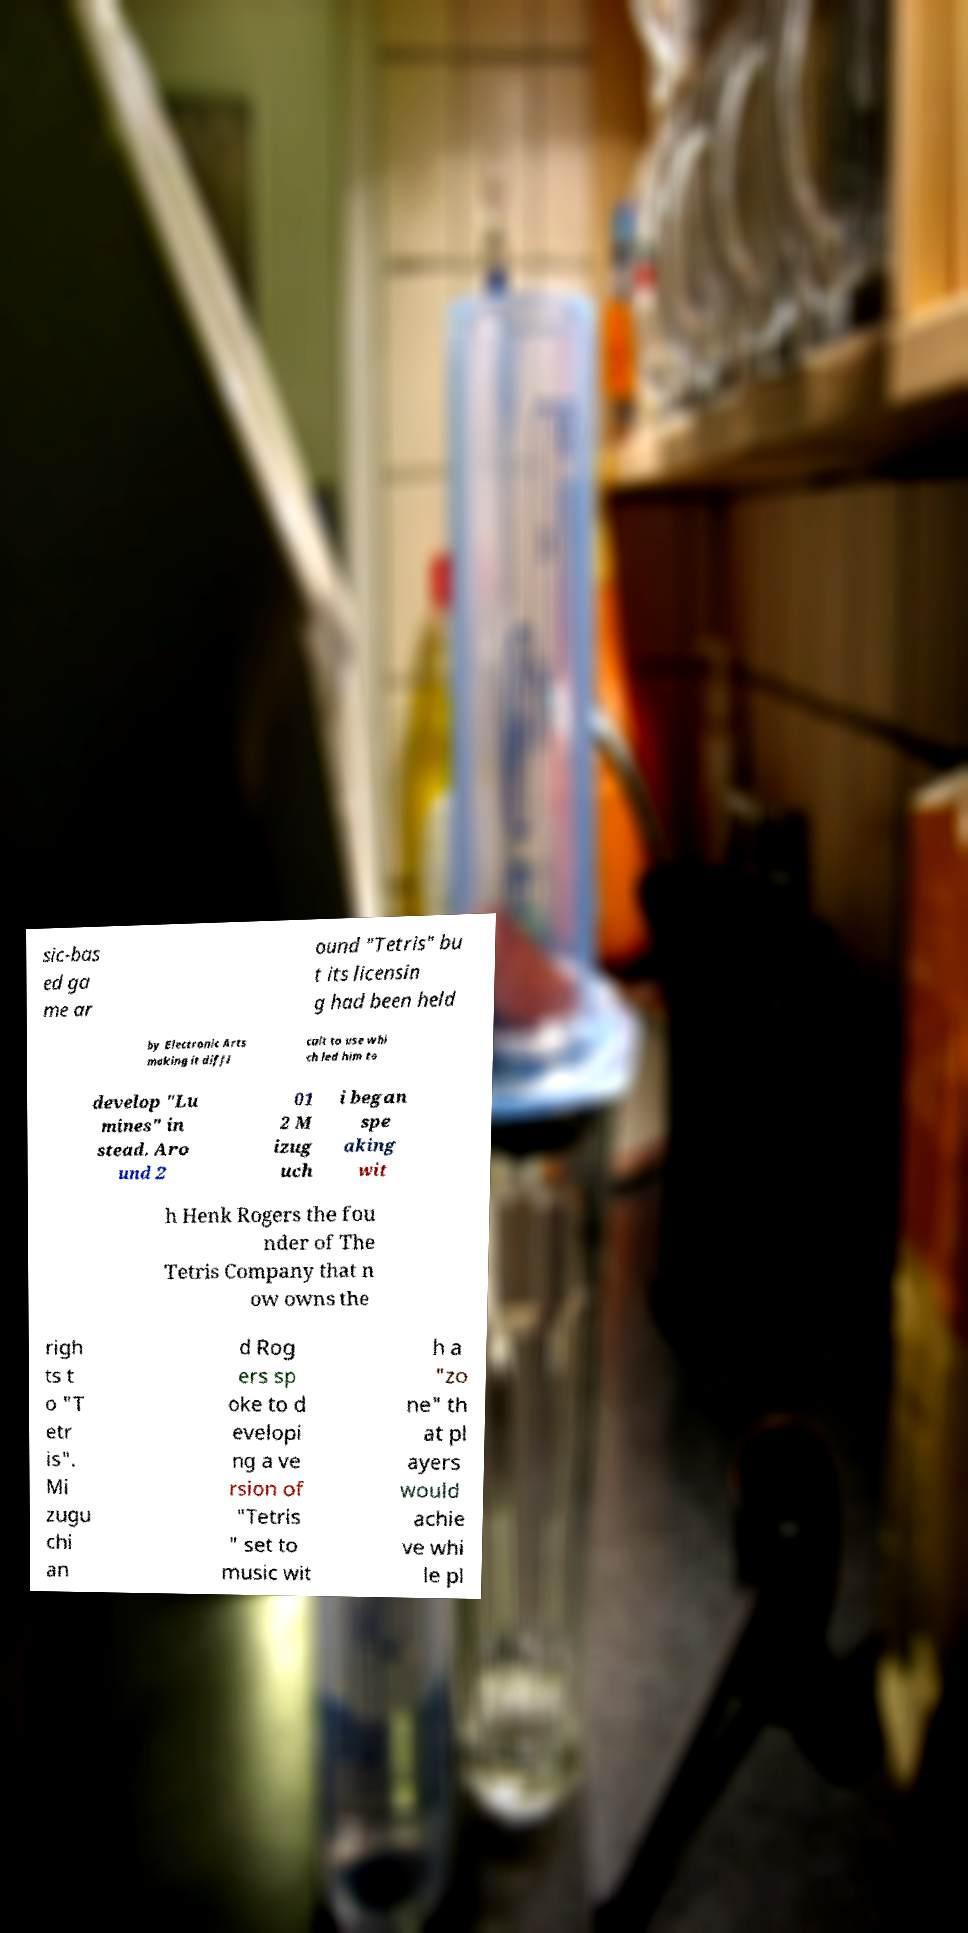There's text embedded in this image that I need extracted. Can you transcribe it verbatim? sic-bas ed ga me ar ound "Tetris" bu t its licensin g had been held by Electronic Arts making it diffi cult to use whi ch led him to develop "Lu mines" in stead. Aro und 2 01 2 M izug uch i began spe aking wit h Henk Rogers the fou nder of The Tetris Company that n ow owns the righ ts t o "T etr is". Mi zugu chi an d Rog ers sp oke to d evelopi ng a ve rsion of "Tetris " set to music wit h a "zo ne" th at pl ayers would achie ve whi le pl 